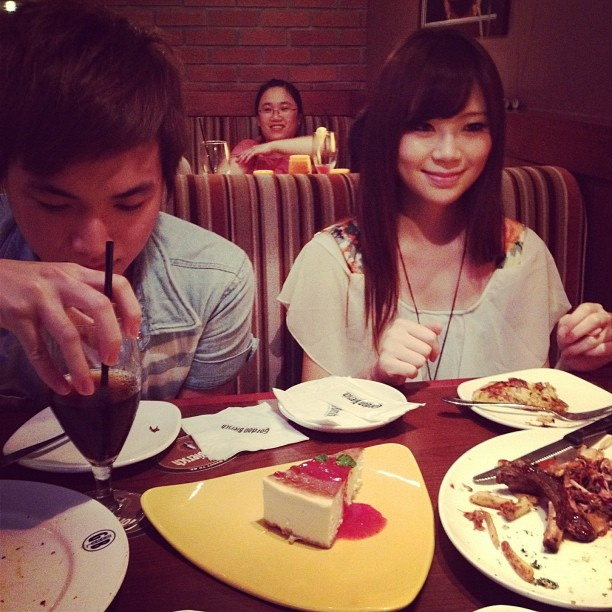Describe the objects in this image and their specific colors. I can see dining table in black, tan, khaki, maroon, and lightyellow tones, people in black, tan, and maroon tones, people in black, maroon, darkgray, and gray tones, chair in black, maroon, and brown tones, and people in black, brown, and maroon tones in this image. 